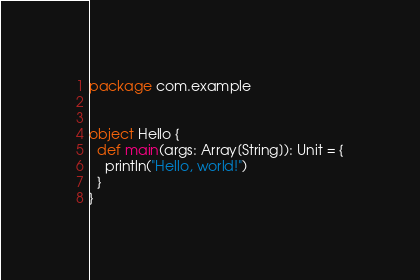<code> <loc_0><loc_0><loc_500><loc_500><_Scala_>package com.example


object Hello {
  def main(args: Array[String]): Unit = {
    println("Hello, world!")
  }
}
</code> 